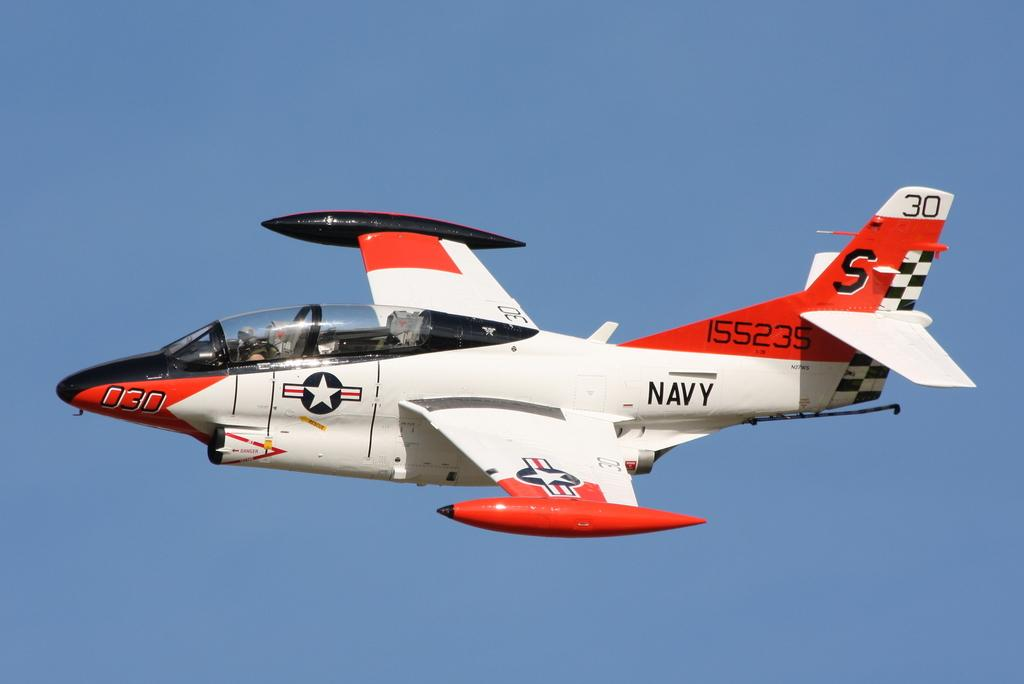<image>
Write a terse but informative summary of the picture. A Navy airplane, numbered 030, is painted red, black, and white. 